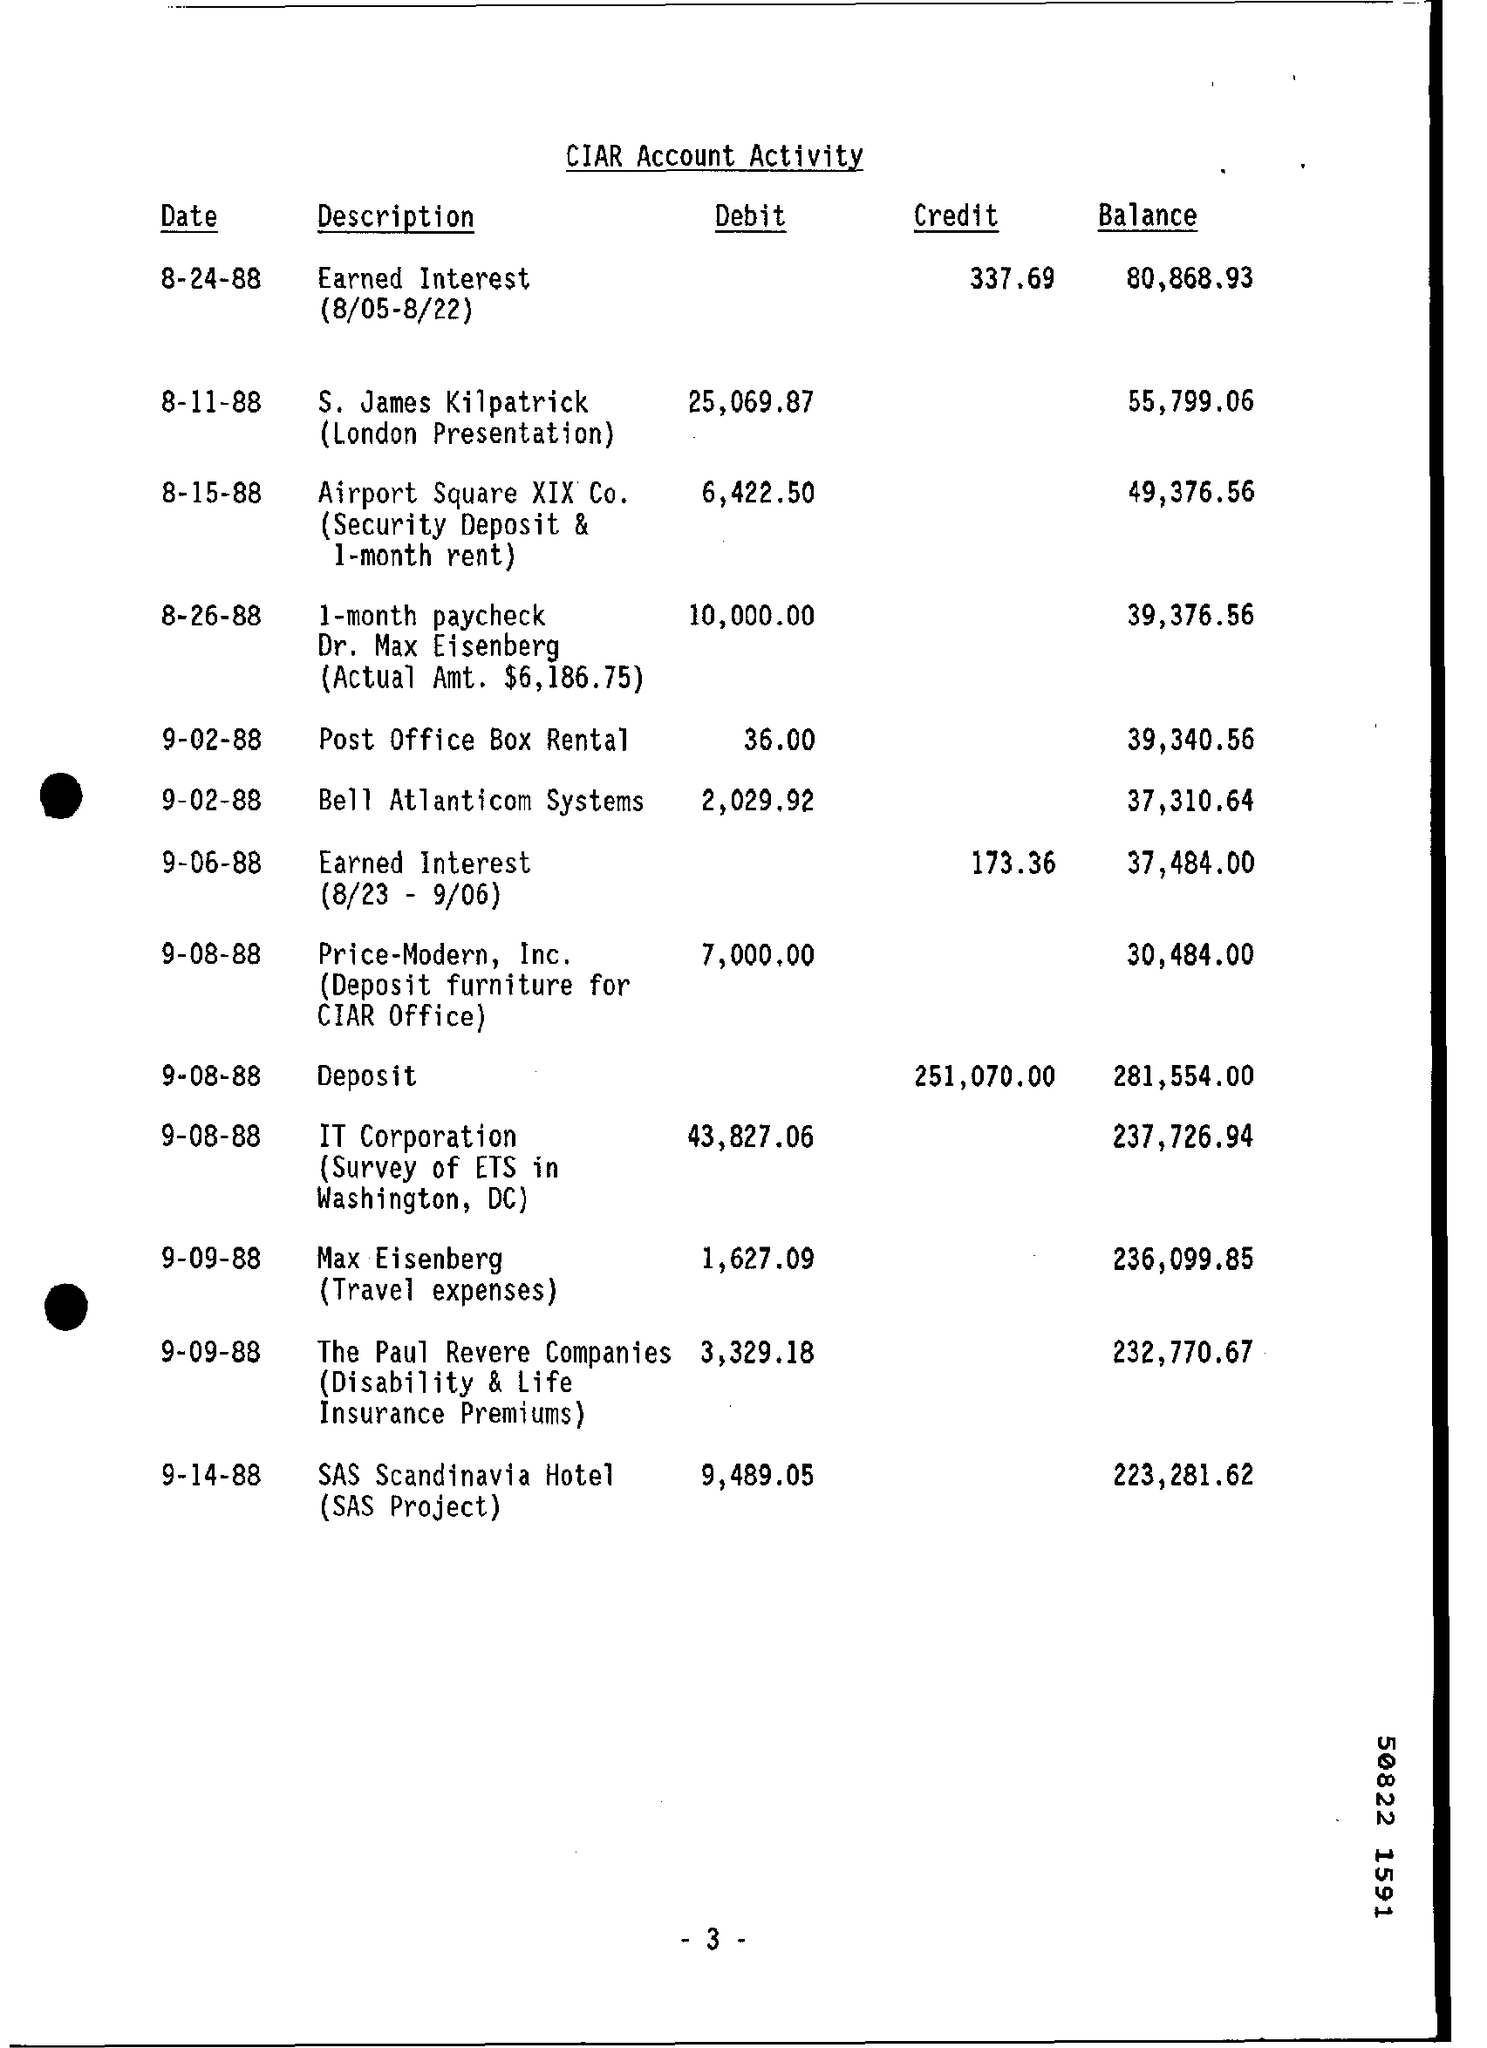What is the balance amount of bell atlanticom systems as of 9-02-88 ?
Your answer should be compact. 37,310.64. What is the debit amount of s.james kilpatrick on 8-11-88 ?
Your answer should be very brief. 25,069.87. How much amount is debited on post  office box rental on 9-02-88 ?
Your answer should be compact. 36.00. What is the balance amount of sas scandinavia hotel on 9-14-88 ?
Your answer should be compact. 223,281.62. How much amount is debited by it corporation on 9-08-88 ?
Give a very brief answer. 43,827.06. What is the balance amount of the paul revere companies on 9-09-88 ?
Give a very brief answer. 232,770.67. How much amount is debited in max eisenberg on 9-09-88 ?
Your response must be concise. 1,627.09. 